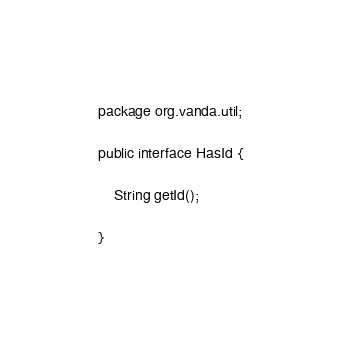<code> <loc_0><loc_0><loc_500><loc_500><_Java_>package org.vanda.util;

public interface HasId {
	
	String getId();

}
</code> 